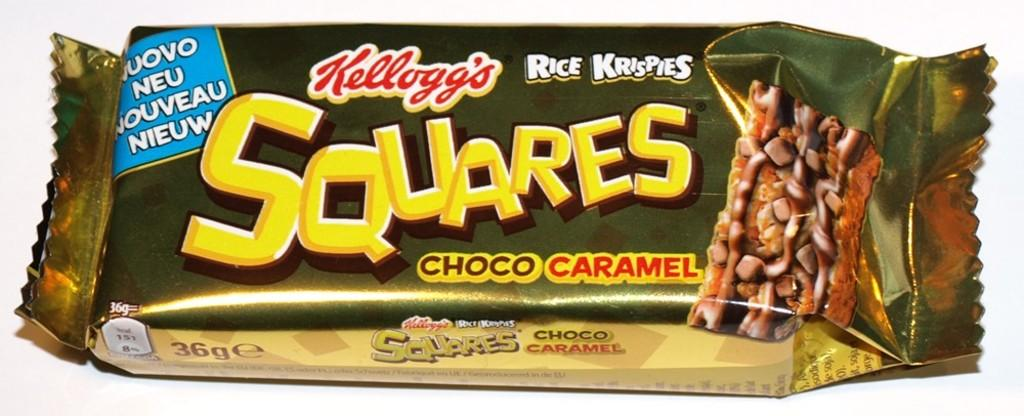What is the main subject of the image? The main subject of the image is a chocolate packet. What can be seen on the chocolate packet? The chocolate packet has text and a picture of a chocolate on it. What is the color of the background in the image? The background of the image is white. Can you tell me what type of record is playing in the background of the image? There is no record or music playing in the image; it only features a chocolate packet with a white background. Is there a coat visible on the chocolate in the image? There is no coat present on the chocolate in the image; it only has a picture of a chocolate on the chocolate packet. 